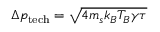Convert formula to latex. <formula><loc_0><loc_0><loc_500><loc_500>\Delta p _ { t e c h } = \sqrt { 4 m _ { s } k _ { B } T _ { B } \gamma \tau }</formula> 